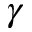<formula> <loc_0><loc_0><loc_500><loc_500>\gamma</formula> 